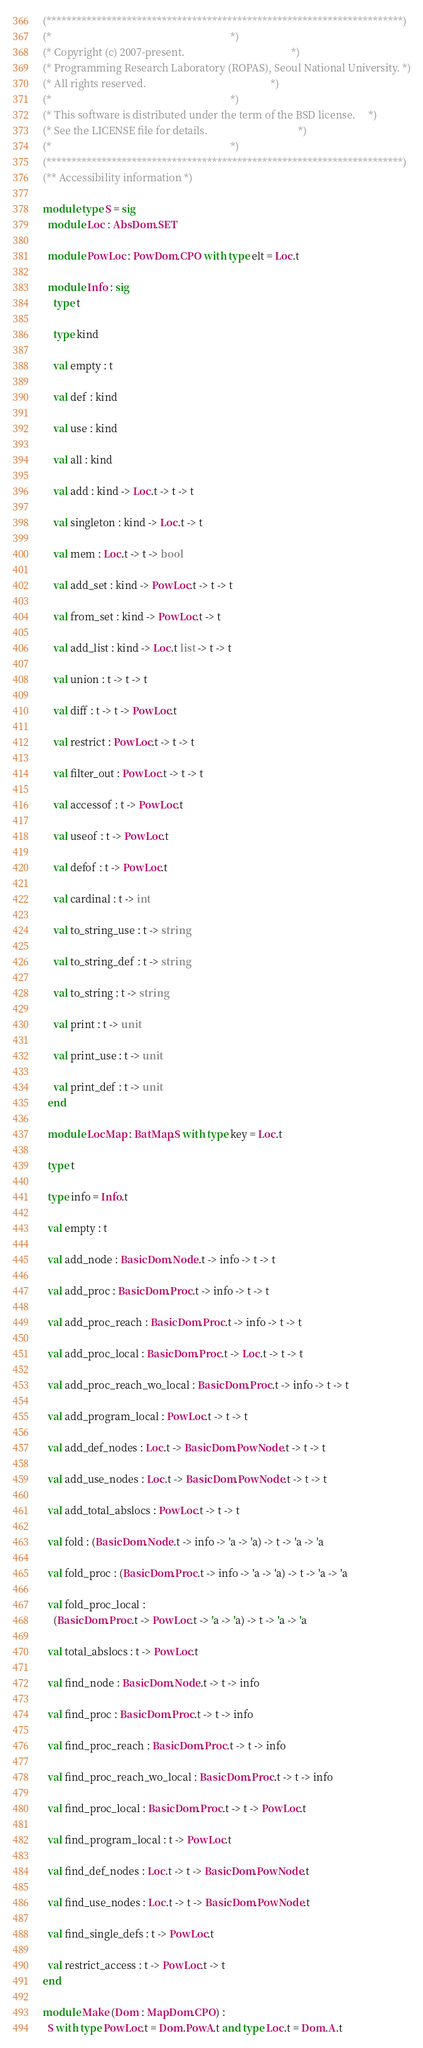<code> <loc_0><loc_0><loc_500><loc_500><_OCaml_>(***********************************************************************)
(*                                                                     *)
(* Copyright (c) 2007-present.                                         *)
(* Programming Research Laboratory (ROPAS), Seoul National University. *)
(* All rights reserved.                                                *)
(*                                                                     *)
(* This software is distributed under the term of the BSD license.     *)
(* See the LICENSE file for details.                                   *)
(*                                                                     *)
(***********************************************************************)
(** Accessibility information *)

module type S = sig
  module Loc : AbsDom.SET

  module PowLoc : PowDom.CPO with type elt = Loc.t

  module Info : sig
    type t

    type kind

    val empty : t

    val def : kind

    val use : kind

    val all : kind

    val add : kind -> Loc.t -> t -> t

    val singleton : kind -> Loc.t -> t

    val mem : Loc.t -> t -> bool

    val add_set : kind -> PowLoc.t -> t -> t

    val from_set : kind -> PowLoc.t -> t

    val add_list : kind -> Loc.t list -> t -> t

    val union : t -> t -> t

    val diff : t -> t -> PowLoc.t

    val restrict : PowLoc.t -> t -> t

    val filter_out : PowLoc.t -> t -> t

    val accessof : t -> PowLoc.t

    val useof : t -> PowLoc.t

    val defof : t -> PowLoc.t

    val cardinal : t -> int

    val to_string_use : t -> string

    val to_string_def : t -> string

    val to_string : t -> string

    val print : t -> unit

    val print_use : t -> unit

    val print_def : t -> unit
  end

  module LocMap : BatMap.S with type key = Loc.t

  type t

  type info = Info.t

  val empty : t

  val add_node : BasicDom.Node.t -> info -> t -> t

  val add_proc : BasicDom.Proc.t -> info -> t -> t

  val add_proc_reach : BasicDom.Proc.t -> info -> t -> t

  val add_proc_local : BasicDom.Proc.t -> Loc.t -> t -> t

  val add_proc_reach_wo_local : BasicDom.Proc.t -> info -> t -> t

  val add_program_local : PowLoc.t -> t -> t

  val add_def_nodes : Loc.t -> BasicDom.PowNode.t -> t -> t

  val add_use_nodes : Loc.t -> BasicDom.PowNode.t -> t -> t

  val add_total_abslocs : PowLoc.t -> t -> t

  val fold : (BasicDom.Node.t -> info -> 'a -> 'a) -> t -> 'a -> 'a

  val fold_proc : (BasicDom.Proc.t -> info -> 'a -> 'a) -> t -> 'a -> 'a

  val fold_proc_local :
    (BasicDom.Proc.t -> PowLoc.t -> 'a -> 'a) -> t -> 'a -> 'a

  val total_abslocs : t -> PowLoc.t

  val find_node : BasicDom.Node.t -> t -> info

  val find_proc : BasicDom.Proc.t -> t -> info

  val find_proc_reach : BasicDom.Proc.t -> t -> info

  val find_proc_reach_wo_local : BasicDom.Proc.t -> t -> info

  val find_proc_local : BasicDom.Proc.t -> t -> PowLoc.t

  val find_program_local : t -> PowLoc.t

  val find_def_nodes : Loc.t -> t -> BasicDom.PowNode.t

  val find_use_nodes : Loc.t -> t -> BasicDom.PowNode.t

  val find_single_defs : t -> PowLoc.t

  val restrict_access : t -> PowLoc.t -> t
end

module Make (Dom : MapDom.CPO) :
  S with type PowLoc.t = Dom.PowA.t and type Loc.t = Dom.A.t
</code> 